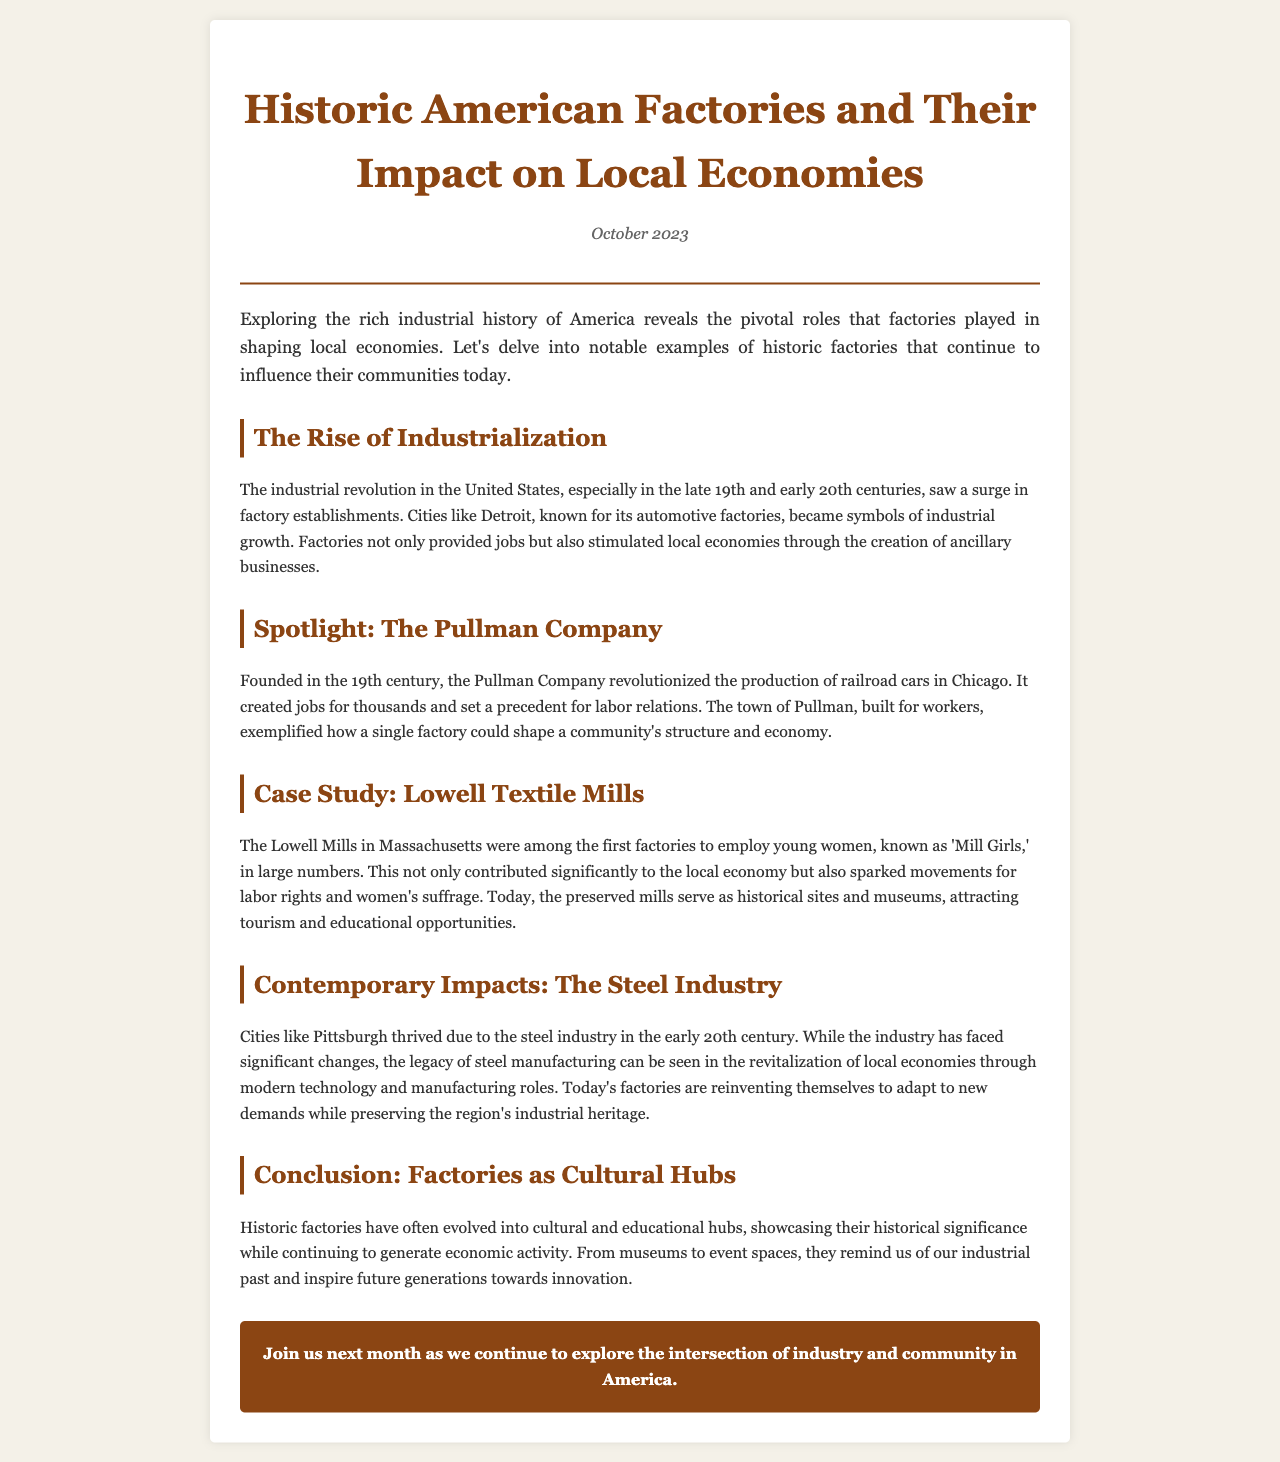What is the title of the newsletter? The title is stated in the header of the document, which is "Historic American Factories and Their Impact on Local Economies."
Answer: Historic American Factories and Their Impact on Local Economies What month and year is this newsletter published? The publication date is mentioned just below the title in the header as "October 2023."
Answer: October 2023 Which company is highlighted in the spotlight section? The spotlight section specifically names a company that played a significant role in the industrial history, which is "The Pullman Company."
Answer: The Pullman Company What significant role did the Lowell Mills play? The section describes the Lowell Mills as employing "young women," which highlights their importance in labor history.
Answer: Employing young women In which city did the Pullman Company primarily operate? The document specifies that the Pullman Company was based in "Chicago."
Answer: Chicago What was the primary industry discussed in relation to Pittsburgh? The newsletter mentions "the steel industry" as the main focus in connection with Pittsburgh’s economic history.
Answer: Steel industry What type of locations have historic factories evolved into? The conclusion of the document states that historic factories have evolved into "cultural and educational hubs."
Answer: Cultural and educational hubs What was the significant influence of factories on local economies during industrialization? The document indicates that factories "stimulated local economies through the creation of ancillary businesses."
Answer: Stimulated local economies How did the newsletter suggest factories impacted the community structure in Pullman? The text notes that the Pullman Company created a town for its workers, demonstrating its impact on community structure.
Answer: Created a town for workers 